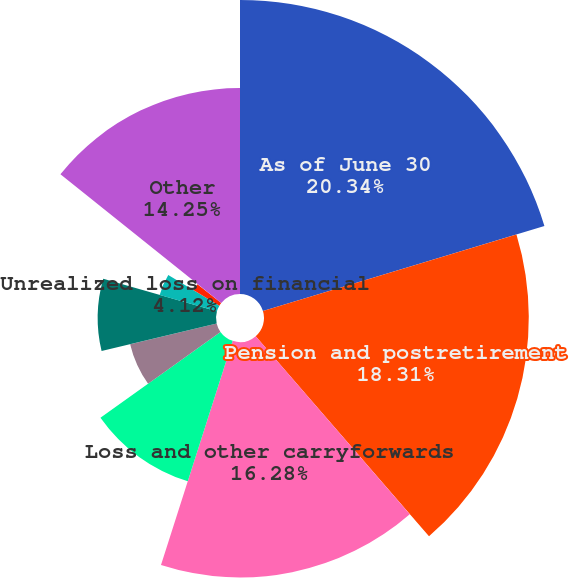Convert chart. <chart><loc_0><loc_0><loc_500><loc_500><pie_chart><fcel>As of June 30<fcel>Pension and postretirement<fcel>Loss and other carryforwards<fcel>Stock-based compensation<fcel>Fixed assets<fcel>Accrued marketing and<fcel>Unrealized loss on financial<fcel>Inventory<fcel>Accrued interest and taxes<fcel>Other<nl><fcel>20.33%<fcel>18.31%<fcel>16.28%<fcel>10.2%<fcel>6.15%<fcel>8.18%<fcel>4.12%<fcel>2.1%<fcel>0.07%<fcel>14.25%<nl></chart> 